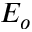Convert formula to latex. <formula><loc_0><loc_0><loc_500><loc_500>E _ { o }</formula> 